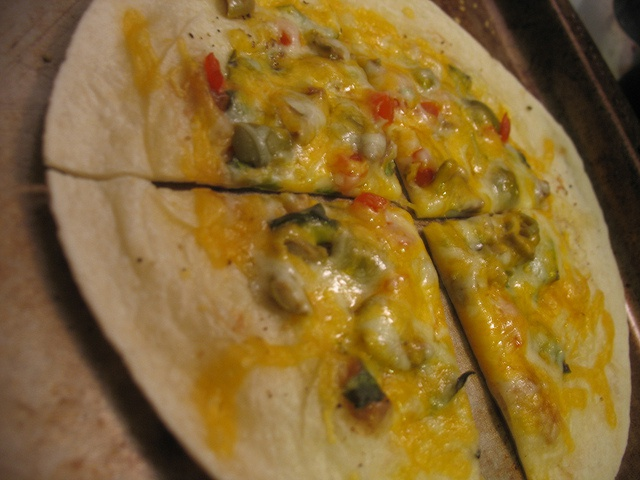Describe the objects in this image and their specific colors. I can see pizza in olive, tan, and black tones and dining table in black, brown, gray, and maroon tones in this image. 